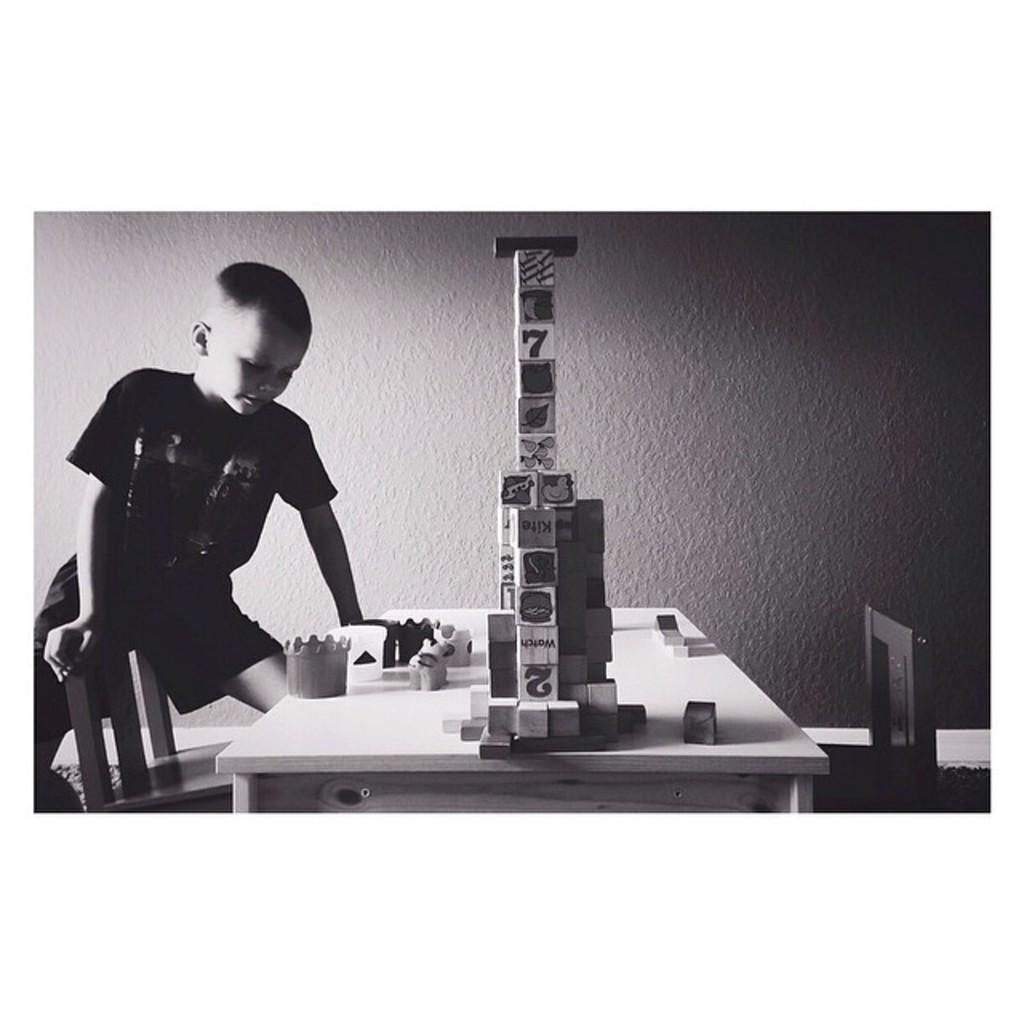Who is in the picture? There is a boy in the picture. Where is the boy located in relation to other objects? The boy is near a table. What can be found on the table? There are playing things on the table. What can be seen in the background of the picture? There is a wall in the background of the picture. What type of canvas is the boy painting on the floor in the image? There is no canvas or painting activity present in the image. 